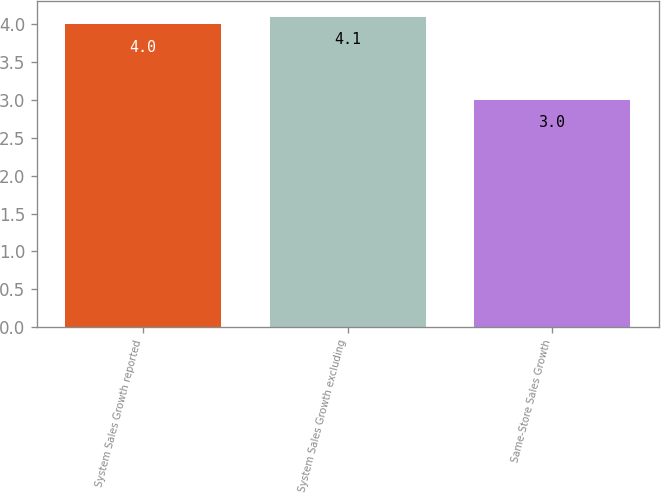Convert chart to OTSL. <chart><loc_0><loc_0><loc_500><loc_500><bar_chart><fcel>System Sales Growth reported<fcel>System Sales Growth excluding<fcel>Same-Store Sales Growth<nl><fcel>4<fcel>4.1<fcel>3<nl></chart> 